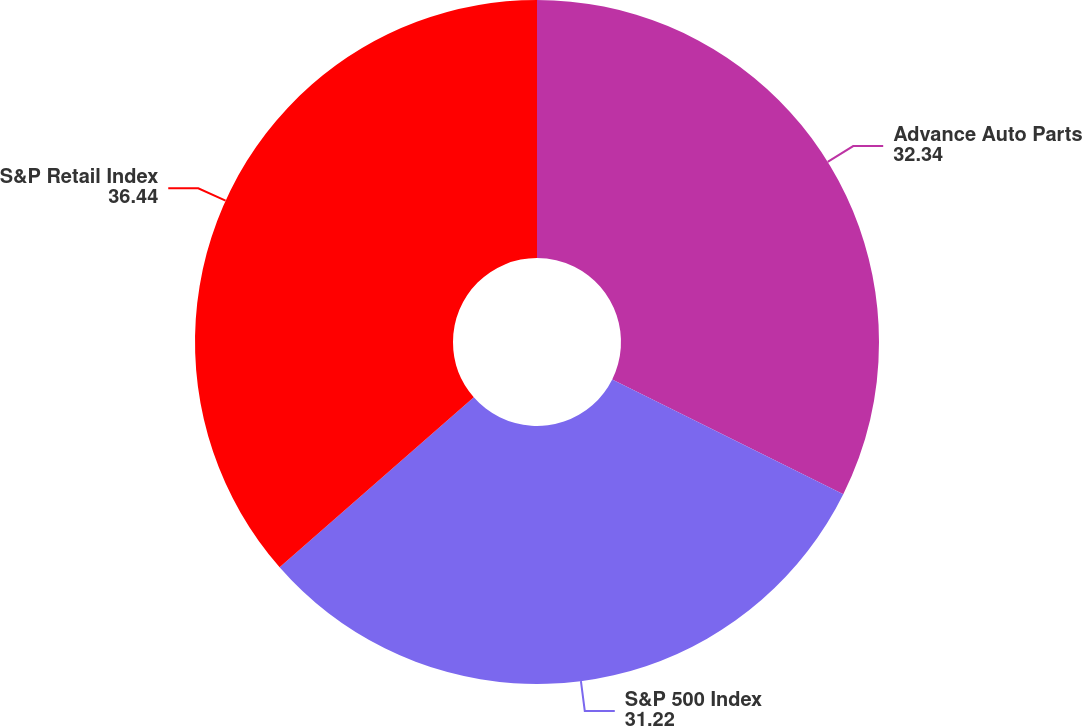Convert chart to OTSL. <chart><loc_0><loc_0><loc_500><loc_500><pie_chart><fcel>Advance Auto Parts<fcel>S&P 500 Index<fcel>S&P Retail Index<nl><fcel>32.34%<fcel>31.22%<fcel>36.44%<nl></chart> 